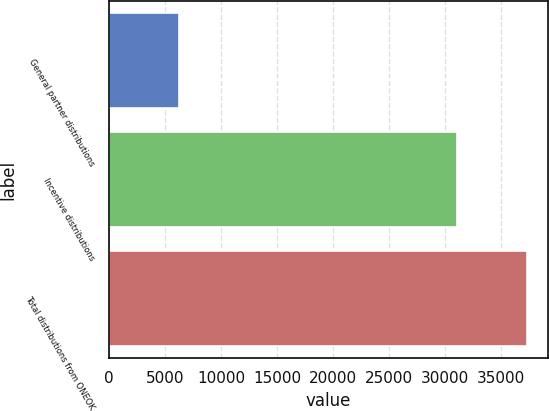Convert chart to OTSL. <chart><loc_0><loc_0><loc_500><loc_500><bar_chart><fcel>General partner distributions<fcel>Incentive distributions<fcel>Total distributions from ONEOK<nl><fcel>6228<fcel>31102<fcel>37330<nl></chart> 